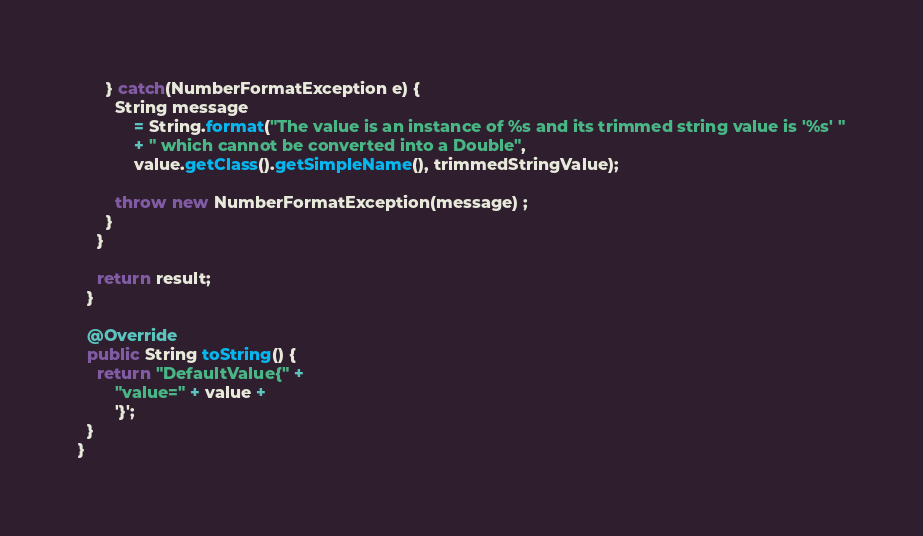<code> <loc_0><loc_0><loc_500><loc_500><_Java_>      } catch(NumberFormatException e) {
        String message
            = String.format("The value is an instance of %s and its trimmed string value is '%s' "
            + " which cannot be converted into a Double",
            value.getClass().getSimpleName(), trimmedStringValue);

        throw new NumberFormatException(message) ;
      }
    }

    return result;
  }

  @Override
  public String toString() {
    return "DefaultValue{" +
        "value=" + value +
        '}';
  }
}
</code> 